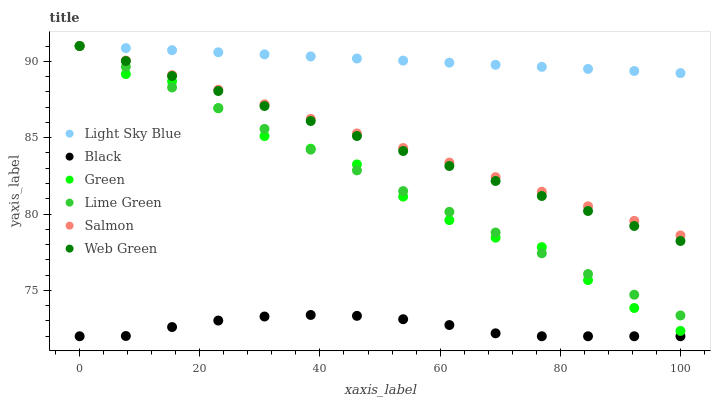Does Black have the minimum area under the curve?
Answer yes or no. Yes. Does Light Sky Blue have the maximum area under the curve?
Answer yes or no. Yes. Does Web Green have the minimum area under the curve?
Answer yes or no. No. Does Web Green have the maximum area under the curve?
Answer yes or no. No. Is Light Sky Blue the smoothest?
Answer yes or no. Yes. Is Green the roughest?
Answer yes or no. Yes. Is Web Green the smoothest?
Answer yes or no. No. Is Web Green the roughest?
Answer yes or no. No. Does Black have the lowest value?
Answer yes or no. Yes. Does Web Green have the lowest value?
Answer yes or no. No. Does Lime Green have the highest value?
Answer yes or no. Yes. Does Black have the highest value?
Answer yes or no. No. Is Black less than Lime Green?
Answer yes or no. Yes. Is Green greater than Black?
Answer yes or no. Yes. Does Green intersect Light Sky Blue?
Answer yes or no. Yes. Is Green less than Light Sky Blue?
Answer yes or no. No. Is Green greater than Light Sky Blue?
Answer yes or no. No. Does Black intersect Lime Green?
Answer yes or no. No. 